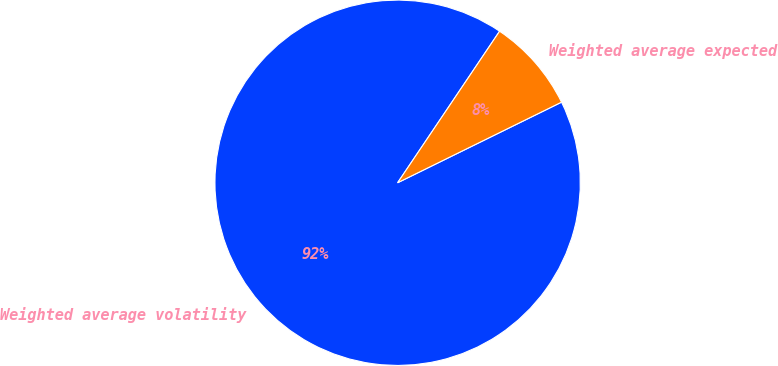Convert chart to OTSL. <chart><loc_0><loc_0><loc_500><loc_500><pie_chart><fcel>Weighted average volatility<fcel>Weighted average expected<nl><fcel>91.7%<fcel>8.3%<nl></chart> 